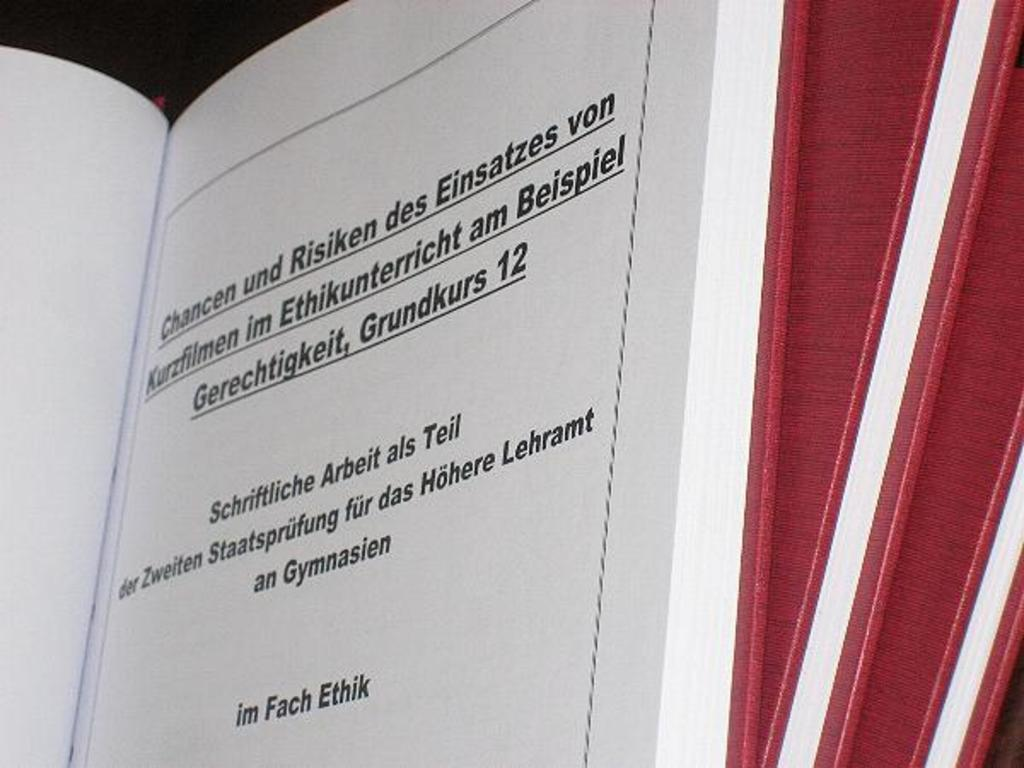<image>
Present a compact description of the photo's key features. a book with German words like Chancen und Risken open 